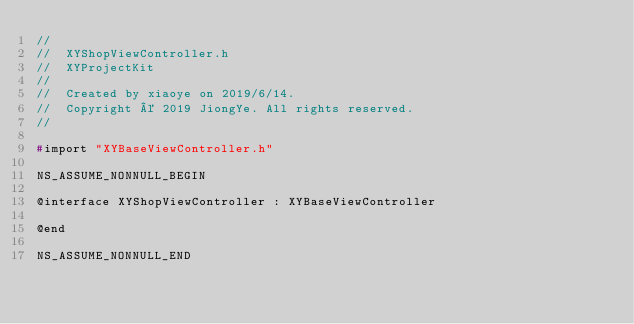<code> <loc_0><loc_0><loc_500><loc_500><_C_>//
//  XYShopViewController.h
//  XYProjectKit
//
//  Created by xiaoye on 2019/6/14.
//  Copyright © 2019 JiongYe. All rights reserved.
//

#import "XYBaseViewController.h"

NS_ASSUME_NONNULL_BEGIN

@interface XYShopViewController : XYBaseViewController

@end

NS_ASSUME_NONNULL_END
</code> 